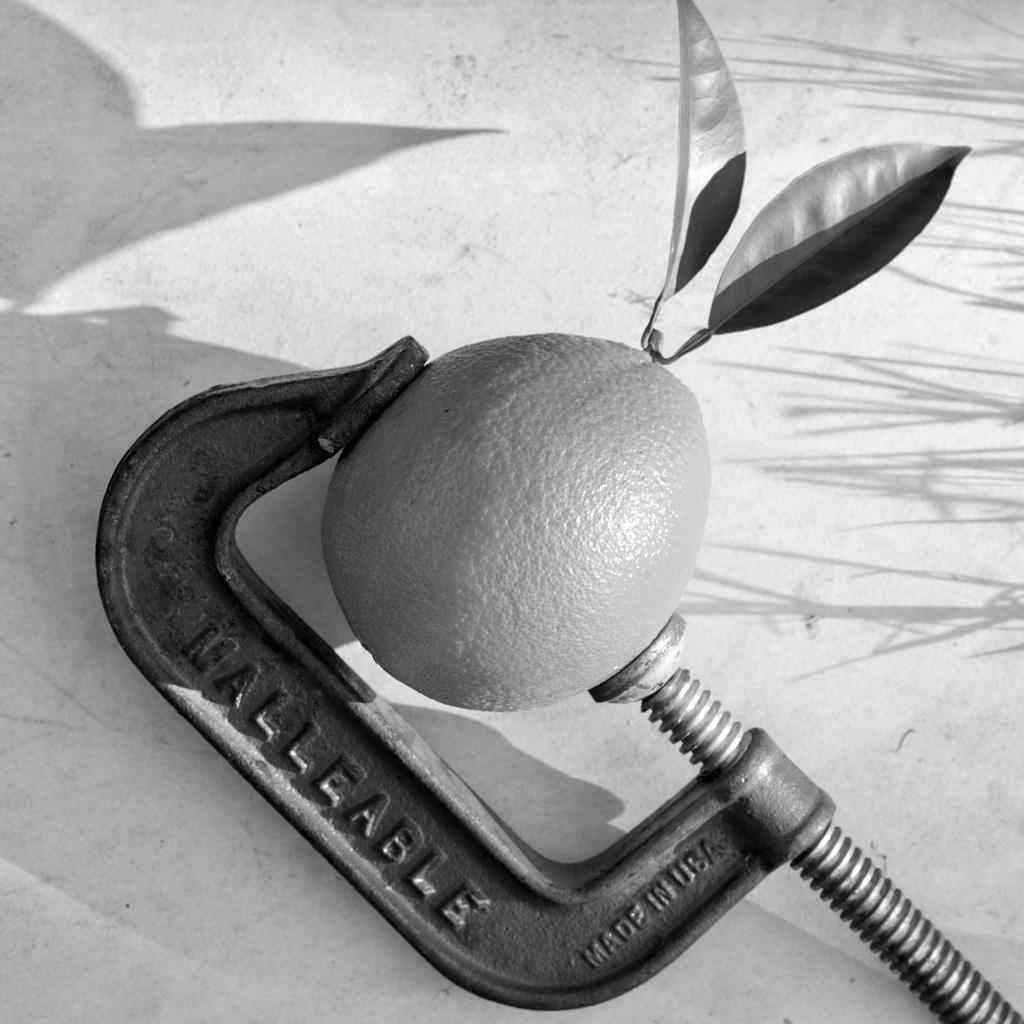<image>
Give a short and clear explanation of the subsequent image. a malleable tool is holding an orange with a leaf 